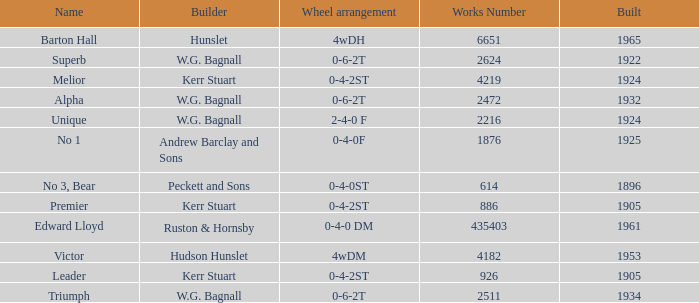What is the work number for Victor? 4182.0. 